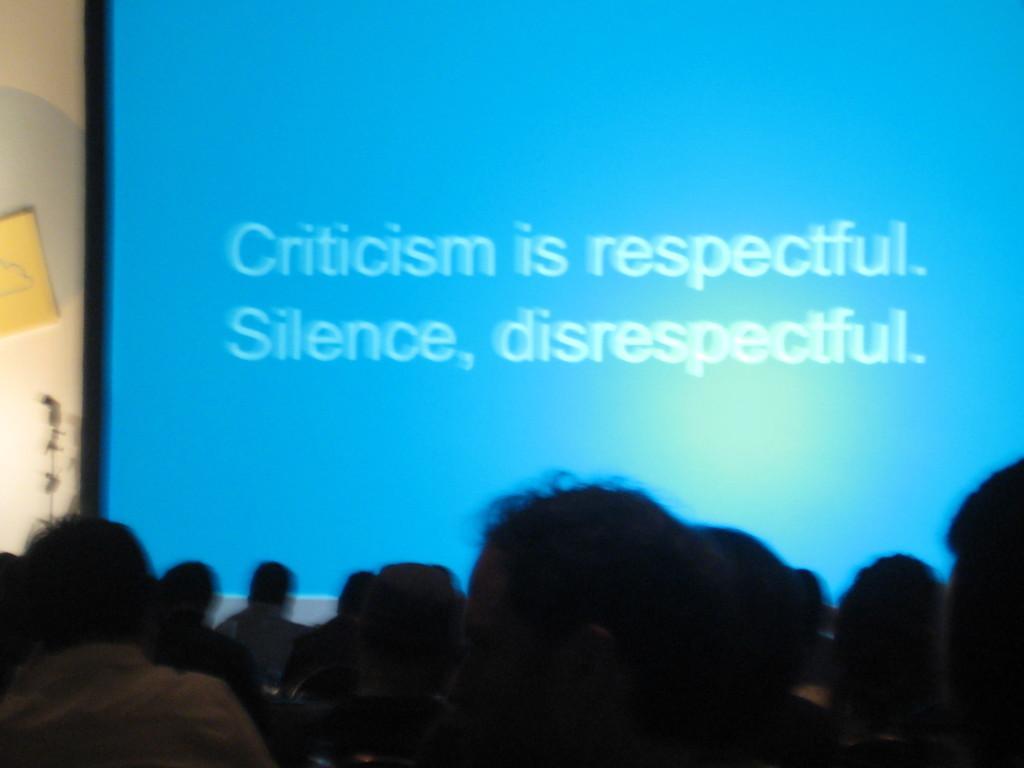In one or two sentences, can you explain what this image depicts? In the image there is a projector screen and some quotation is being displayed on that screen and in the front there are a lot of people gathered and behind the projector screen there is a wall. 